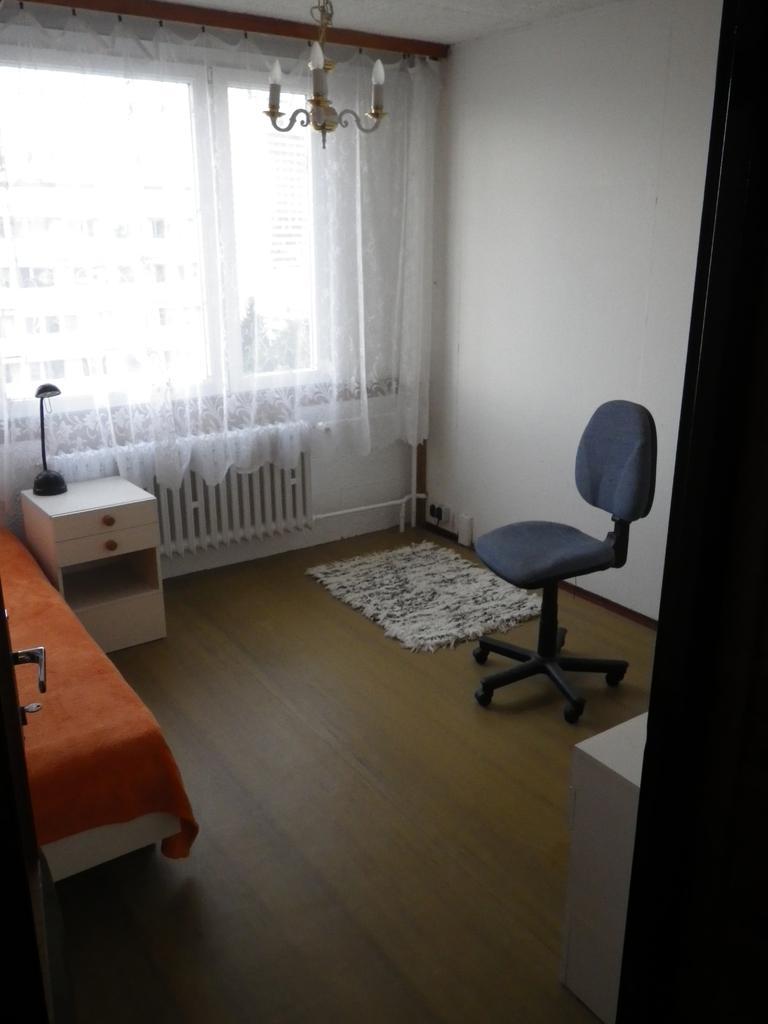In one or two sentences, can you explain what this image depicts? This is an inside view of a room. On the left side there is a door, a bed and a table. On the right side there is a chair on the floor. Beside the chair there is a mat. In the background there is a curtain to the window. At the top of the image there is a chandelier. 